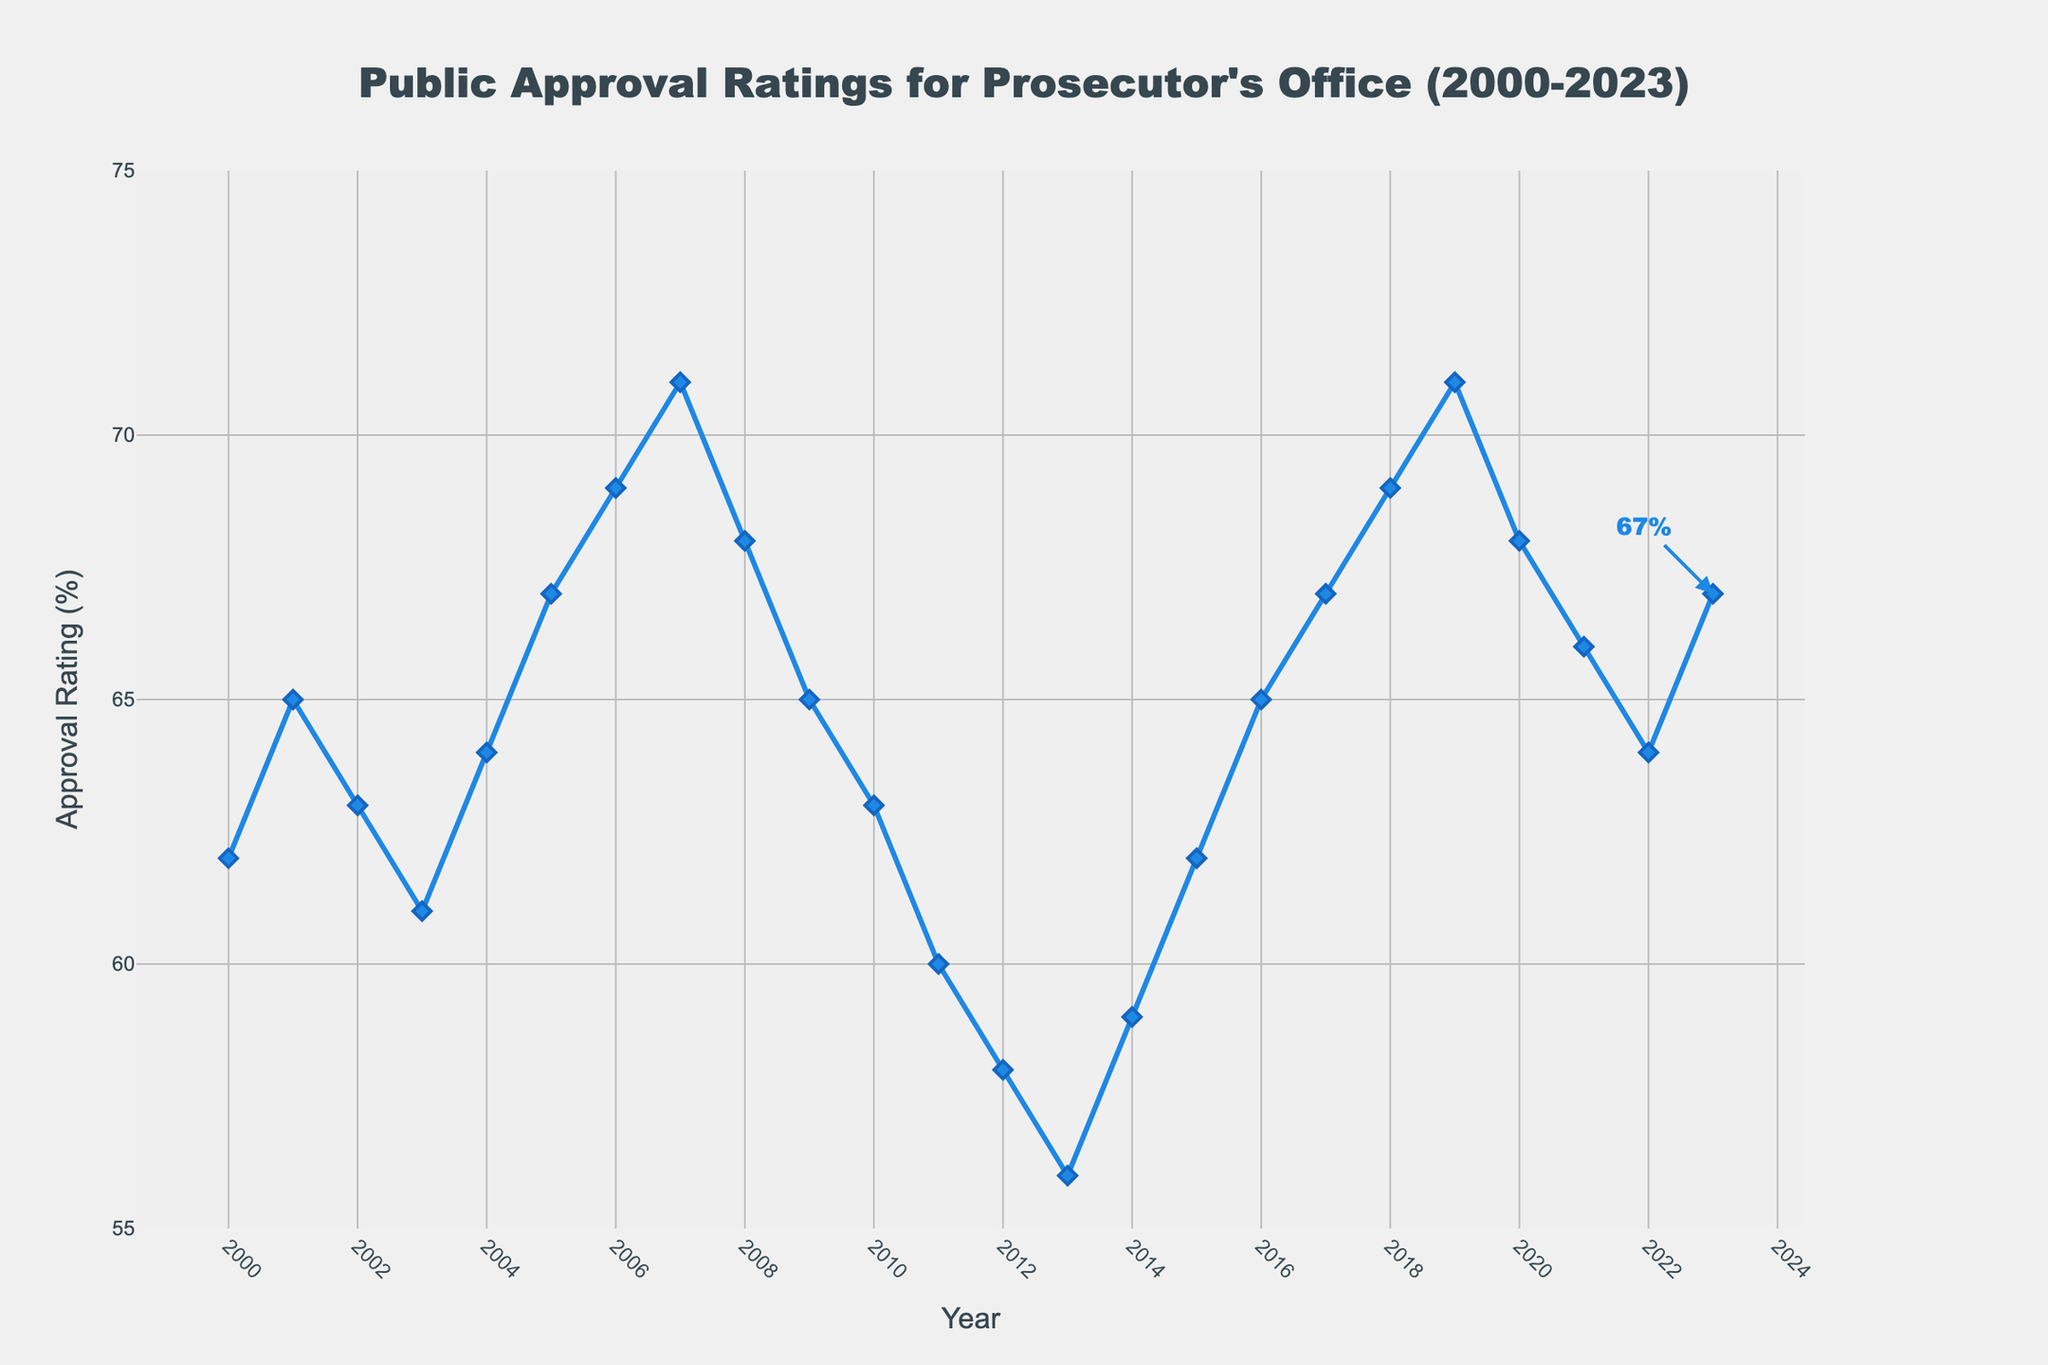What year experienced the highest public approval rating? The highest point on the line chart is at 2007 and 2019 with an approval rating of 71%.
Answer: 2007 and 2019 How does the approval rating in 2023 compare to that in 2020? In 2023, the approval rating is 67%, while in 2020, it was 68%. 67% is slightly lower than 68%.
Answer: 2023 is lower Which years saw a decrease in approval rating compared to the previous year? By observing the line chart's dips, the years with a decline in the approval rating from the previous year are 2003, 2008, 2009, 2011, 2012, 2013, 2020, and 2021.
Answer: 2003, 2008, 2009, 2011, 2012, 2013, 2020, 2021 What's the average approval rating over the period 2000-2023? Sum the approval ratings from 2000 to 2023, then divide by the number of years (24): (62 + 65 + 63 + 61 + 64 + 67 + 69 + 71 + 68 + 65 + 63 + 60 + 58 + 56 + 59 + 62 + 65 + 67 + 69 + 71 + 68 + 66 + 64 + 67) / 24 = 1524 / 24 = 63.5%
Answer: 63.5% In which years did the approval rating reach or exceed 70%? The line chart shows that the approval rating hit or exceeded 70% in the years 2007 and 2019.
Answer: 2007 and 2019 By how much did the approval rating change from 2001 to 2002? The approval rating in 2001 was 65% and in 2002 it was 63%. The change is 65% - 63% = 2%.
Answer: 2% Is there a trend observed in the approval ratings in the first five years (2000-2004)? From 2000 to 2004, the approval rating shows small fluctuations around 62-65%, indicating stabilization within a narrow range.
Answer: Stabilizing What's the difference in approval rating between the highest and lowest years? The highest approval rating is 71% (2007, 2019), and the lowest is 56% (2013). The difference is 71% - 56% = 15%.
Answer: 15% In which years did approval ratings improve for three consecutive years? The approval rating improves consecutively from 2004 to 2007 and from 2014 to 2017.
Answer: 2004-2007, 2014-2017 What trend can be observed in the approval rating from 2015 to 2023? From 2015 to 2023, the approval rating generally increases from 62% to 67%, with some fluctuations.
Answer: Increasing trend with fluctuations 